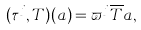<formula> <loc_0><loc_0><loc_500><loc_500>( \tau ^ { j } , T ) ( a ) & = \varpi ^ { j } \overline { T } a ,</formula> 